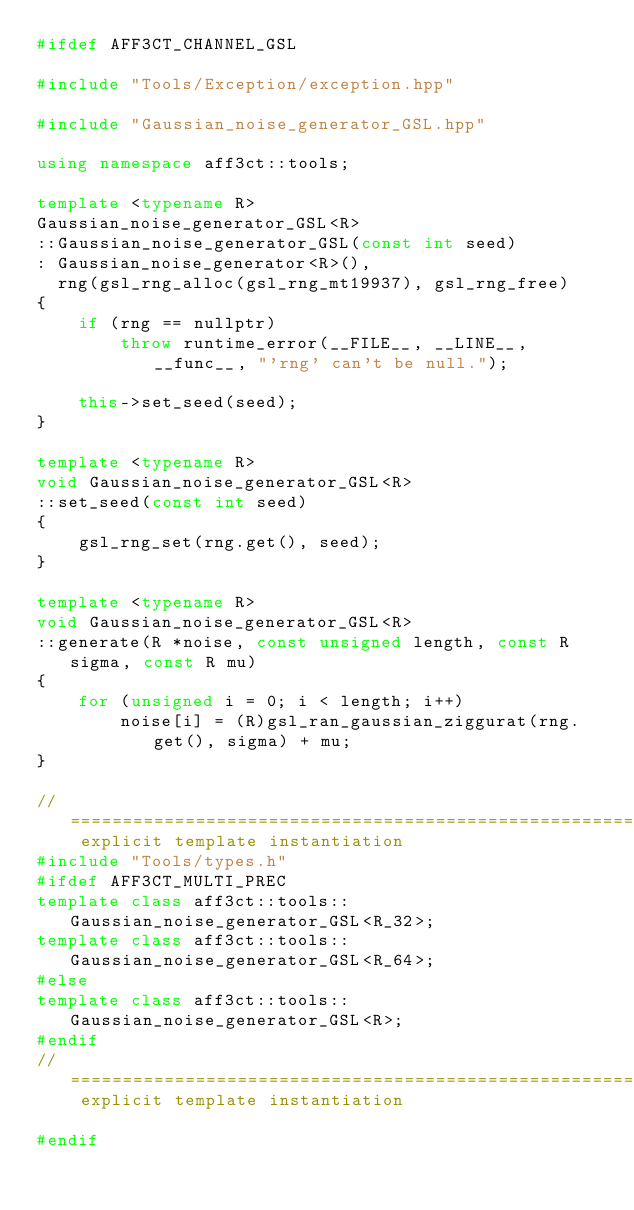<code> <loc_0><loc_0><loc_500><loc_500><_C++_>#ifdef AFF3CT_CHANNEL_GSL

#include "Tools/Exception/exception.hpp"

#include "Gaussian_noise_generator_GSL.hpp"

using namespace aff3ct::tools;

template <typename R>
Gaussian_noise_generator_GSL<R>
::Gaussian_noise_generator_GSL(const int seed)
: Gaussian_noise_generator<R>(),
  rng(gsl_rng_alloc(gsl_rng_mt19937), gsl_rng_free)
{
	if (rng == nullptr)
		throw runtime_error(__FILE__, __LINE__, __func__, "'rng' can't be null.");

	this->set_seed(seed);
}

template <typename R>
void Gaussian_noise_generator_GSL<R>
::set_seed(const int seed)
{
	gsl_rng_set(rng.get(), seed);
}

template <typename R>
void Gaussian_noise_generator_GSL<R>
::generate(R *noise, const unsigned length, const R sigma, const R mu)
{
	for (unsigned i = 0; i < length; i++)
		noise[i] = (R)gsl_ran_gaussian_ziggurat(rng.get(), sigma) + mu;
}

// ==================================================================================== explicit template instantiation
#include "Tools/types.h"
#ifdef AFF3CT_MULTI_PREC
template class aff3ct::tools::Gaussian_noise_generator_GSL<R_32>;
template class aff3ct::tools::Gaussian_noise_generator_GSL<R_64>;
#else
template class aff3ct::tools::Gaussian_noise_generator_GSL<R>;
#endif
// ==================================================================================== explicit template instantiation

#endif
</code> 